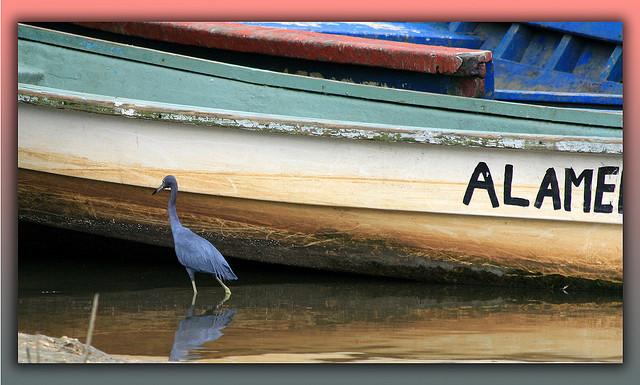Read and extract the text from this image. ALAME 